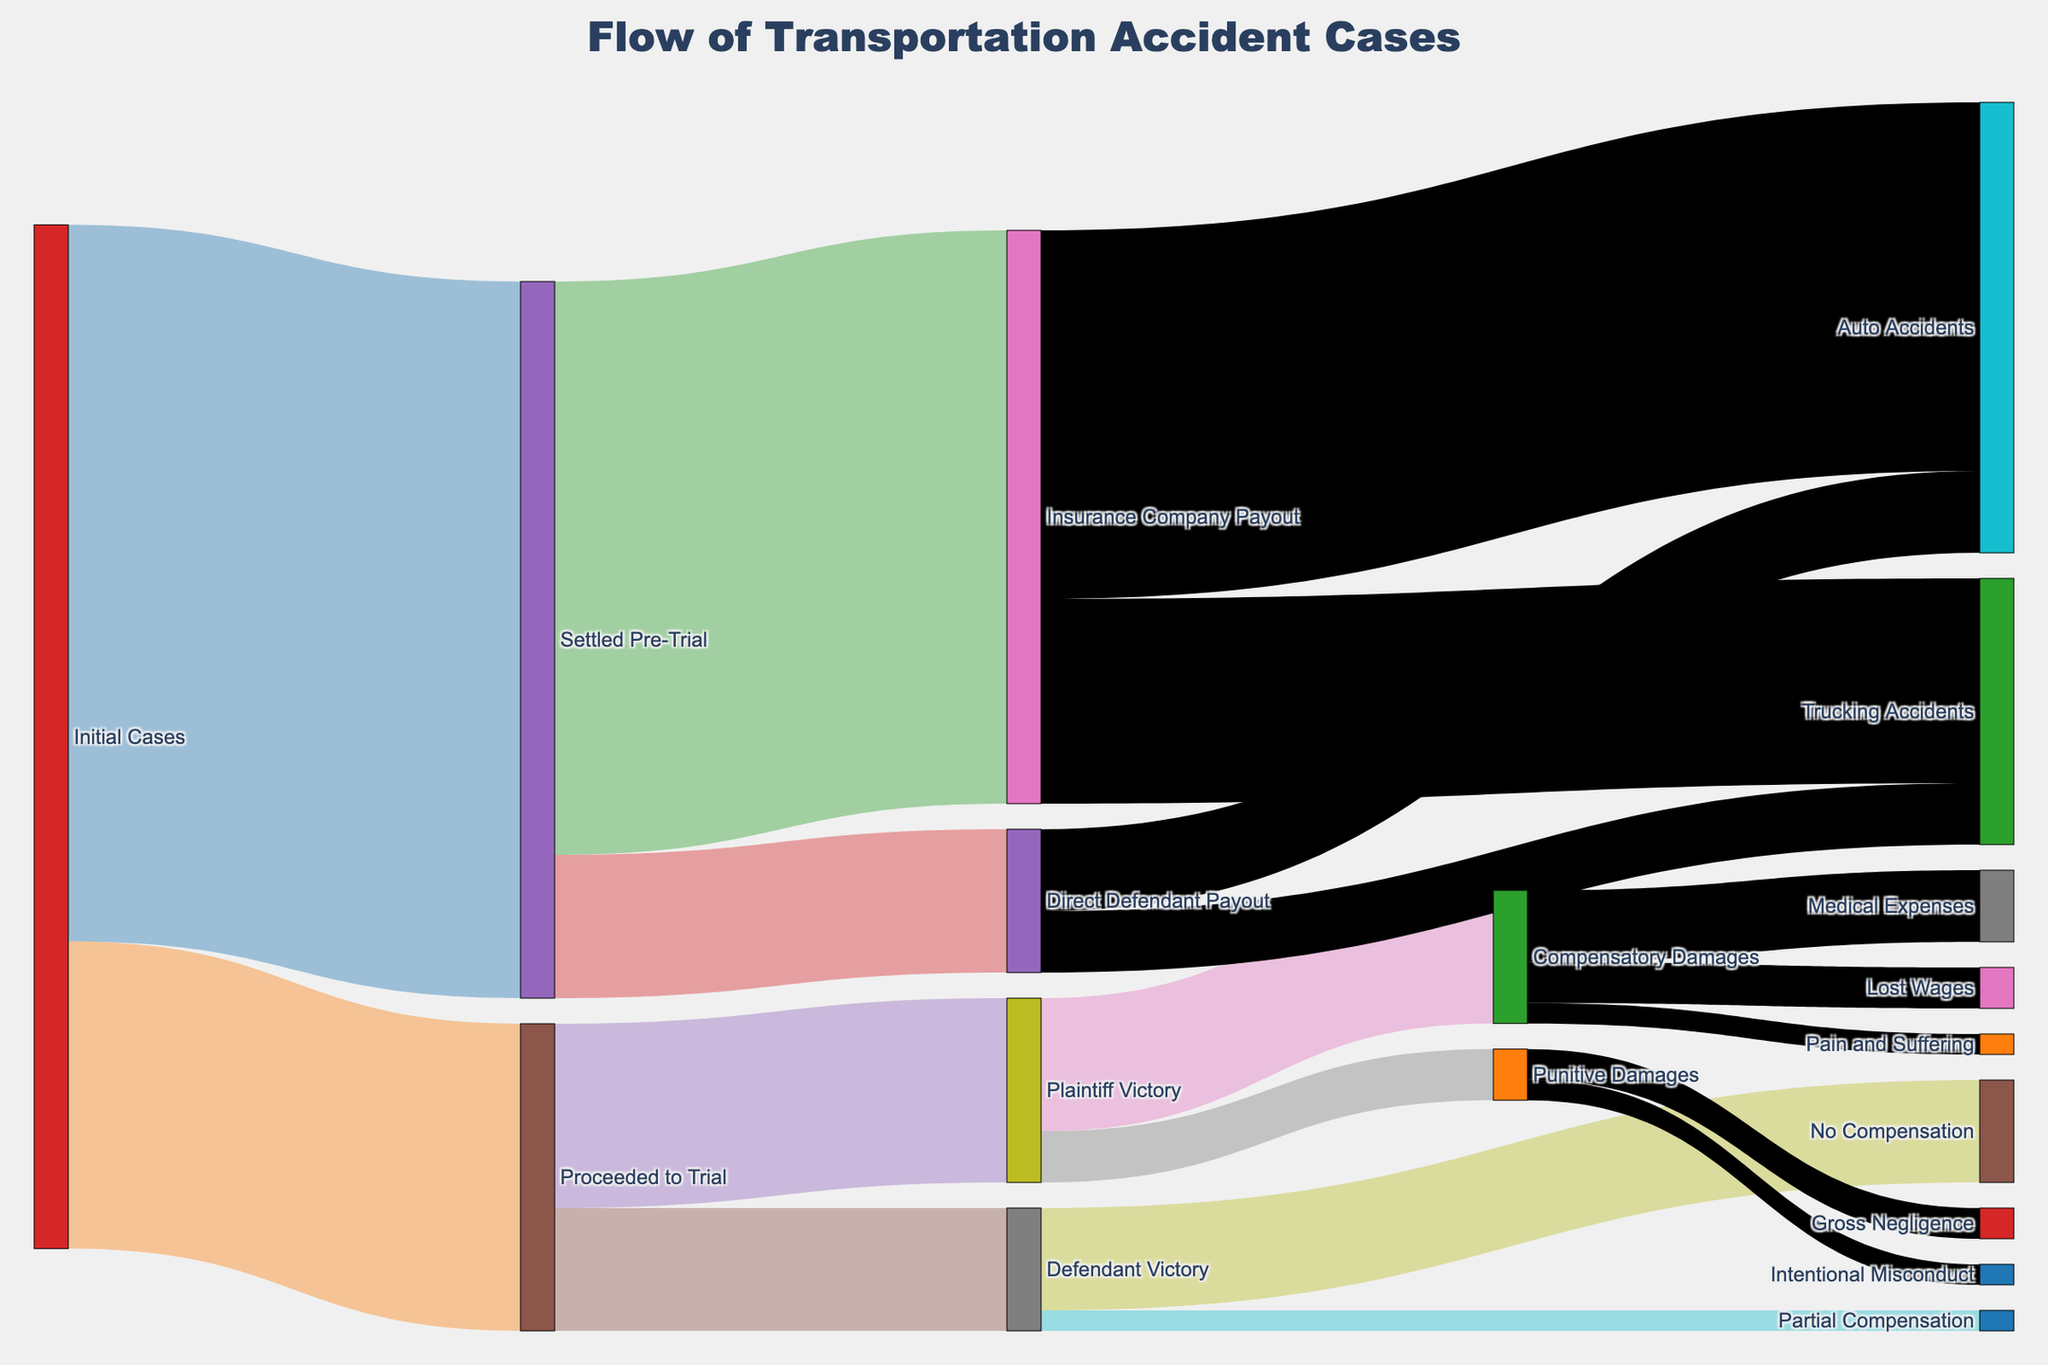What's the title of the diagram? The title is placed prominently at the center top of the figure. It gives an overall description of the diagram's content.
Answer: Flow of Transportation Accident Cases How many initial cases were settled pre-trial? Locate the initial cases node, looking at its outgoing connections to identify the number of cases settled pre-trial.
Answer: 350 Between compensatory damages and punitive damages, which category has more value? Follow the trial path that leads to plaintiff victories and their subsequent damages, comparing the values of compensatory and punitive damages.
Answer: Compensatory Damages What is the total number of initial cases that proceed to trial? Locate the initial cases node and find the connection to cases that proceeded to trial, noting the value associated with it.
Answer: 150 How many cases resulted in plaintiff victories? Follow the path from cases that proceeded to trial and identify the number resulting in plaintiff victories.
Answer: 90 How many compensatory damages are allocated for medical expenses? From plaintiff victories, follow the path to compensatory damages and further to medical expenses, and note the value.
Answer: 35 What is the sum of auto accident payouts from both insurance companies and direct defendants? Follow paths from insurance company and direct defendant payouts to auto accidents, summing their values.
Answer: 220 Are there more auto accident cases or trucking accident cases from insurance payouts? Compare the value paths from insurance company payouts to auto accidents and trucking accidents.
Answer: Auto Accidents Between no compensation and partial compensation in defendant victories, which outcome has a higher value? Follow the trial results to defendant victories, then compare no compensation and partial compensation values.
Answer: No Compensation What percentage of settled cases involved an insurance company payout? Calculate the percentage by taking the insurance company payout from settled pre-trial cases and dividing it by total settled pre-trial cases, then multiplying by 100.
Answer: 80% 